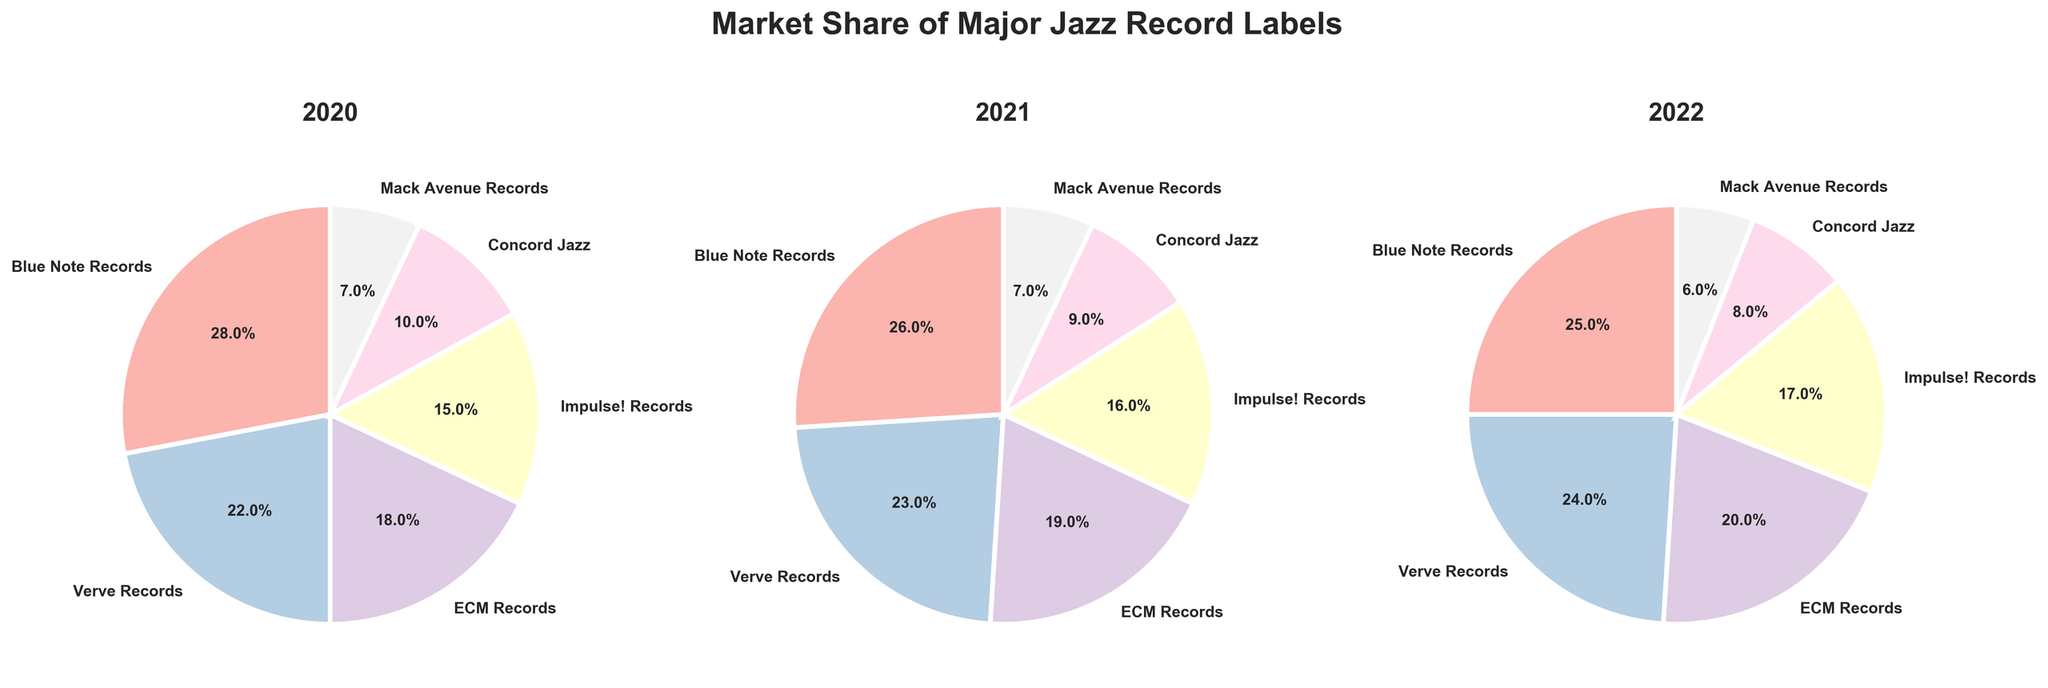What is the market share of Blue Note Records in 2022? The 2022 pie chart shows the market share of Blue Note Records at 25%.
Answer: 25% Which record label had the smallest market share in 2021? In the 2021 pie chart, Mack Avenue Records had the smallest market share at 7%.
Answer: Mack Avenue Records Did the market share of Impulse! Records increase or decrease from 2020 to 2022? By comparing the pie charts for 2020 and 2022, the market share of Impulse! Records increased from 15% to 17%.
Answer: Increased What is the total market share of ECM Records over the three years? ECM Records' market share is 18% in 2020, 19% in 2021, and 20% in 2022. Adding these up: 18 + 19 + 20 = 57%.
Answer: 57% Which label consistently holds the second-highest market share across all three years? Observing all three pie charts, Verve Records holds the second-highest market share in 2020 (22%), 2021 (23%), and 2022 (24%).
Answer: Verve Records What is the average market share of Concord Jazz across the years shown? Concord Jazz's market shares are 10% in 2020, 9% in 2021, and 8% in 2022. (10 + 9 + 8) / 3 = 27 / 3 = 9%.
Answer: 9% By how much did Blue Note Records’ market share decrease from 2020 to 2022? Blue Note Records' market share in 2020 is 28%, and in 2022 it is 25%. The decrease is 28 - 25 = 3%.
Answer: 3% Which two labels combined have the highest market share in 2020? In 2020, Blue Note Records (28%) and Verve Records (22%) combined have the highest market share, totaling 50%.
Answer: Blue Note Records and Verve Records Is there any year where Mack Avenue Records' market share changes? If yes, what is the change and in which year? Yes, Mack Avenue Records' market share changes from 2021 to 2022, decreasing from 7% to 6%, which is a change of 1%.
Answer: Decreased by 1% in 2022 